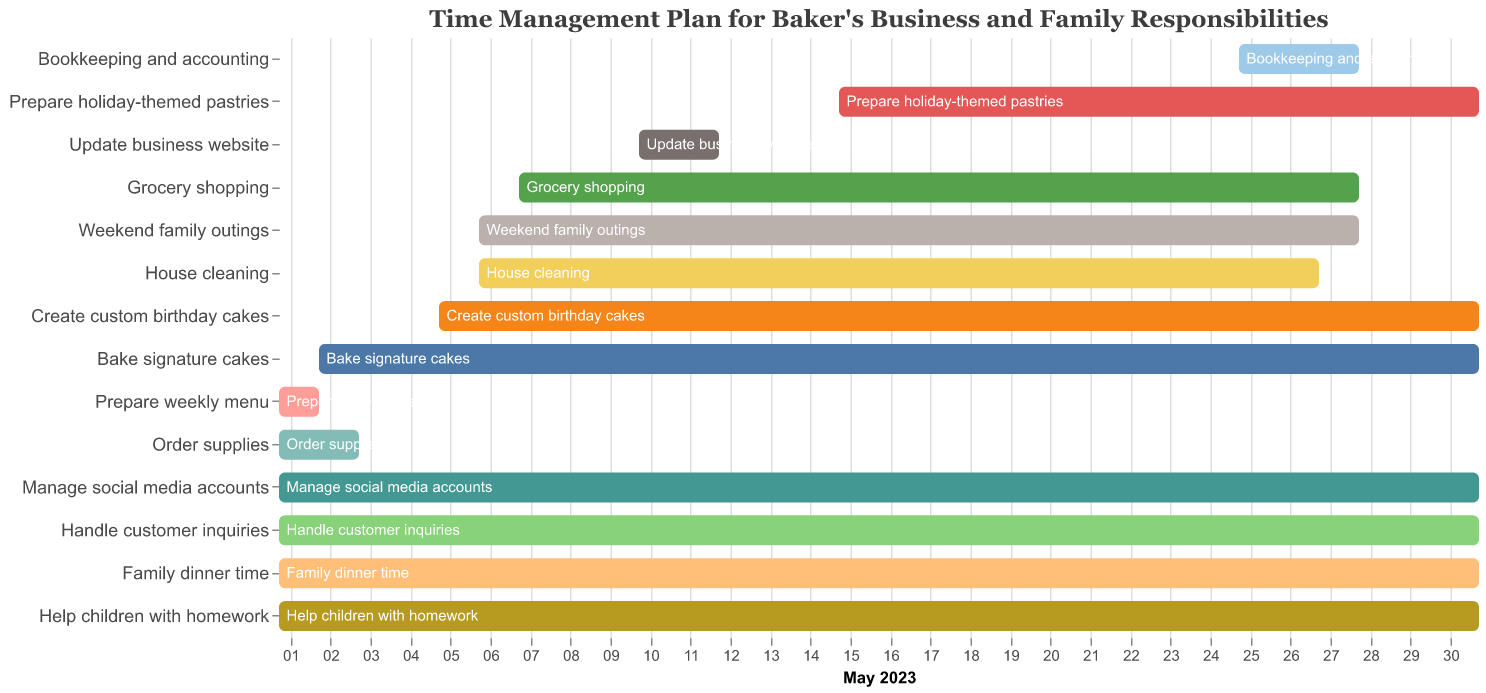What is the title of the Gantt chart? The title is always displayed prominently at the top of the Gantt chart. In this case, it reads: "Time Management Plan for Baker's Business and Family Responsibilities".
Answer: Time Management Plan for Baker's Business and Family Responsibilities What is the longest task in terms of duration? By visually inspecting the length of the bars, 'Handle customer inquiries', 'Manage social media accounts', 'Family dinner time', and 'Help children with homework', which span from May 1 to May 31, have the longest duration.
Answer: 31 days Which task starts on the latest date? Looking at the starting points on the x-axis, 'Bookkeeping and accounting' starts the latest on May 25.
Answer: Bookkeeping and accounting How many tasks end exactly on May 31? Inspecting the end points of each bar, 7 tasks end on May 31: 'Bake signature cakes', 'Create custom birthday cakes', 'Prepare holiday-themed pastries', 'Manage social media accounts', 'Handle customer inquiries', 'Family dinner time', and 'Help children with homework'.
Answer: 7 Which task has the shortest duration? By examining the lengths of all bars, 'Prepare weekly menu' has the shortest duration with just 2 days.
Answer: Prepare weekly menu How much longer is the 'Bake signature cakes' task compared to 'Order supplies'? 'Bake signature cakes' spans from May 2 to May 31, making it 30 days. 'Order supplies' runs from May 1 to May 3, totaling 3 days. The difference is 30 - 3 = 27 days.
Answer: 27 days Which tasks overlap with the 'Prepare holiday-themed pastries' task? 'Prepare holiday-themed pastries' starts on May 15 and ends on May 31. Any tasks that intersect with these dates overlap. These tasks are: 'Bake signature cakes', 'Create custom birthday cakes', 'Manage social media accounts', 'Handle customer inquiries', 'Family dinner time', and 'Help children with homework'.
Answer: 6 tasks What is the combined duration of 'Grocery shopping' and 'House cleaning'? 'Grocery shopping' spans from May 7 to May 28 and 'House cleaning' spans from May 6 to May 27. Their durations are (22 and 22) respectively. The total duration is 22 + 22 = 44 days.
Answer: 44 days 